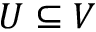<formula> <loc_0><loc_0><loc_500><loc_500>U \subseteq V</formula> 